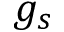<formula> <loc_0><loc_0><loc_500><loc_500>g _ { s }</formula> 